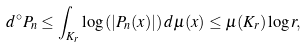<formula> <loc_0><loc_0><loc_500><loc_500>d ^ { \circ } P _ { n } \leq \int _ { K _ { r } } \log \left ( | P _ { n } ( x ) | \right ) d \mu ( x ) \leq \mu ( K _ { r } ) \log r ,</formula> 